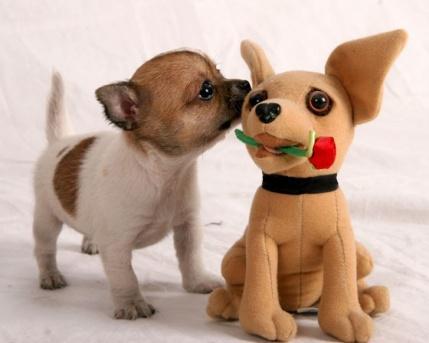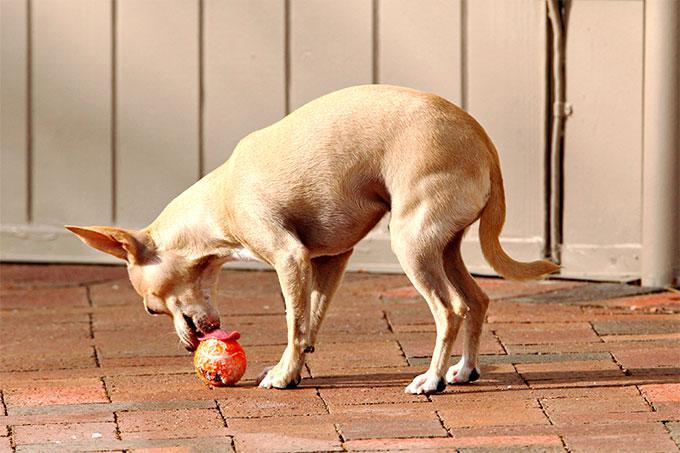The first image is the image on the left, the second image is the image on the right. Evaluate the accuracy of this statement regarding the images: "Each image includes just one dog.". Is it true? Answer yes or no. No. 